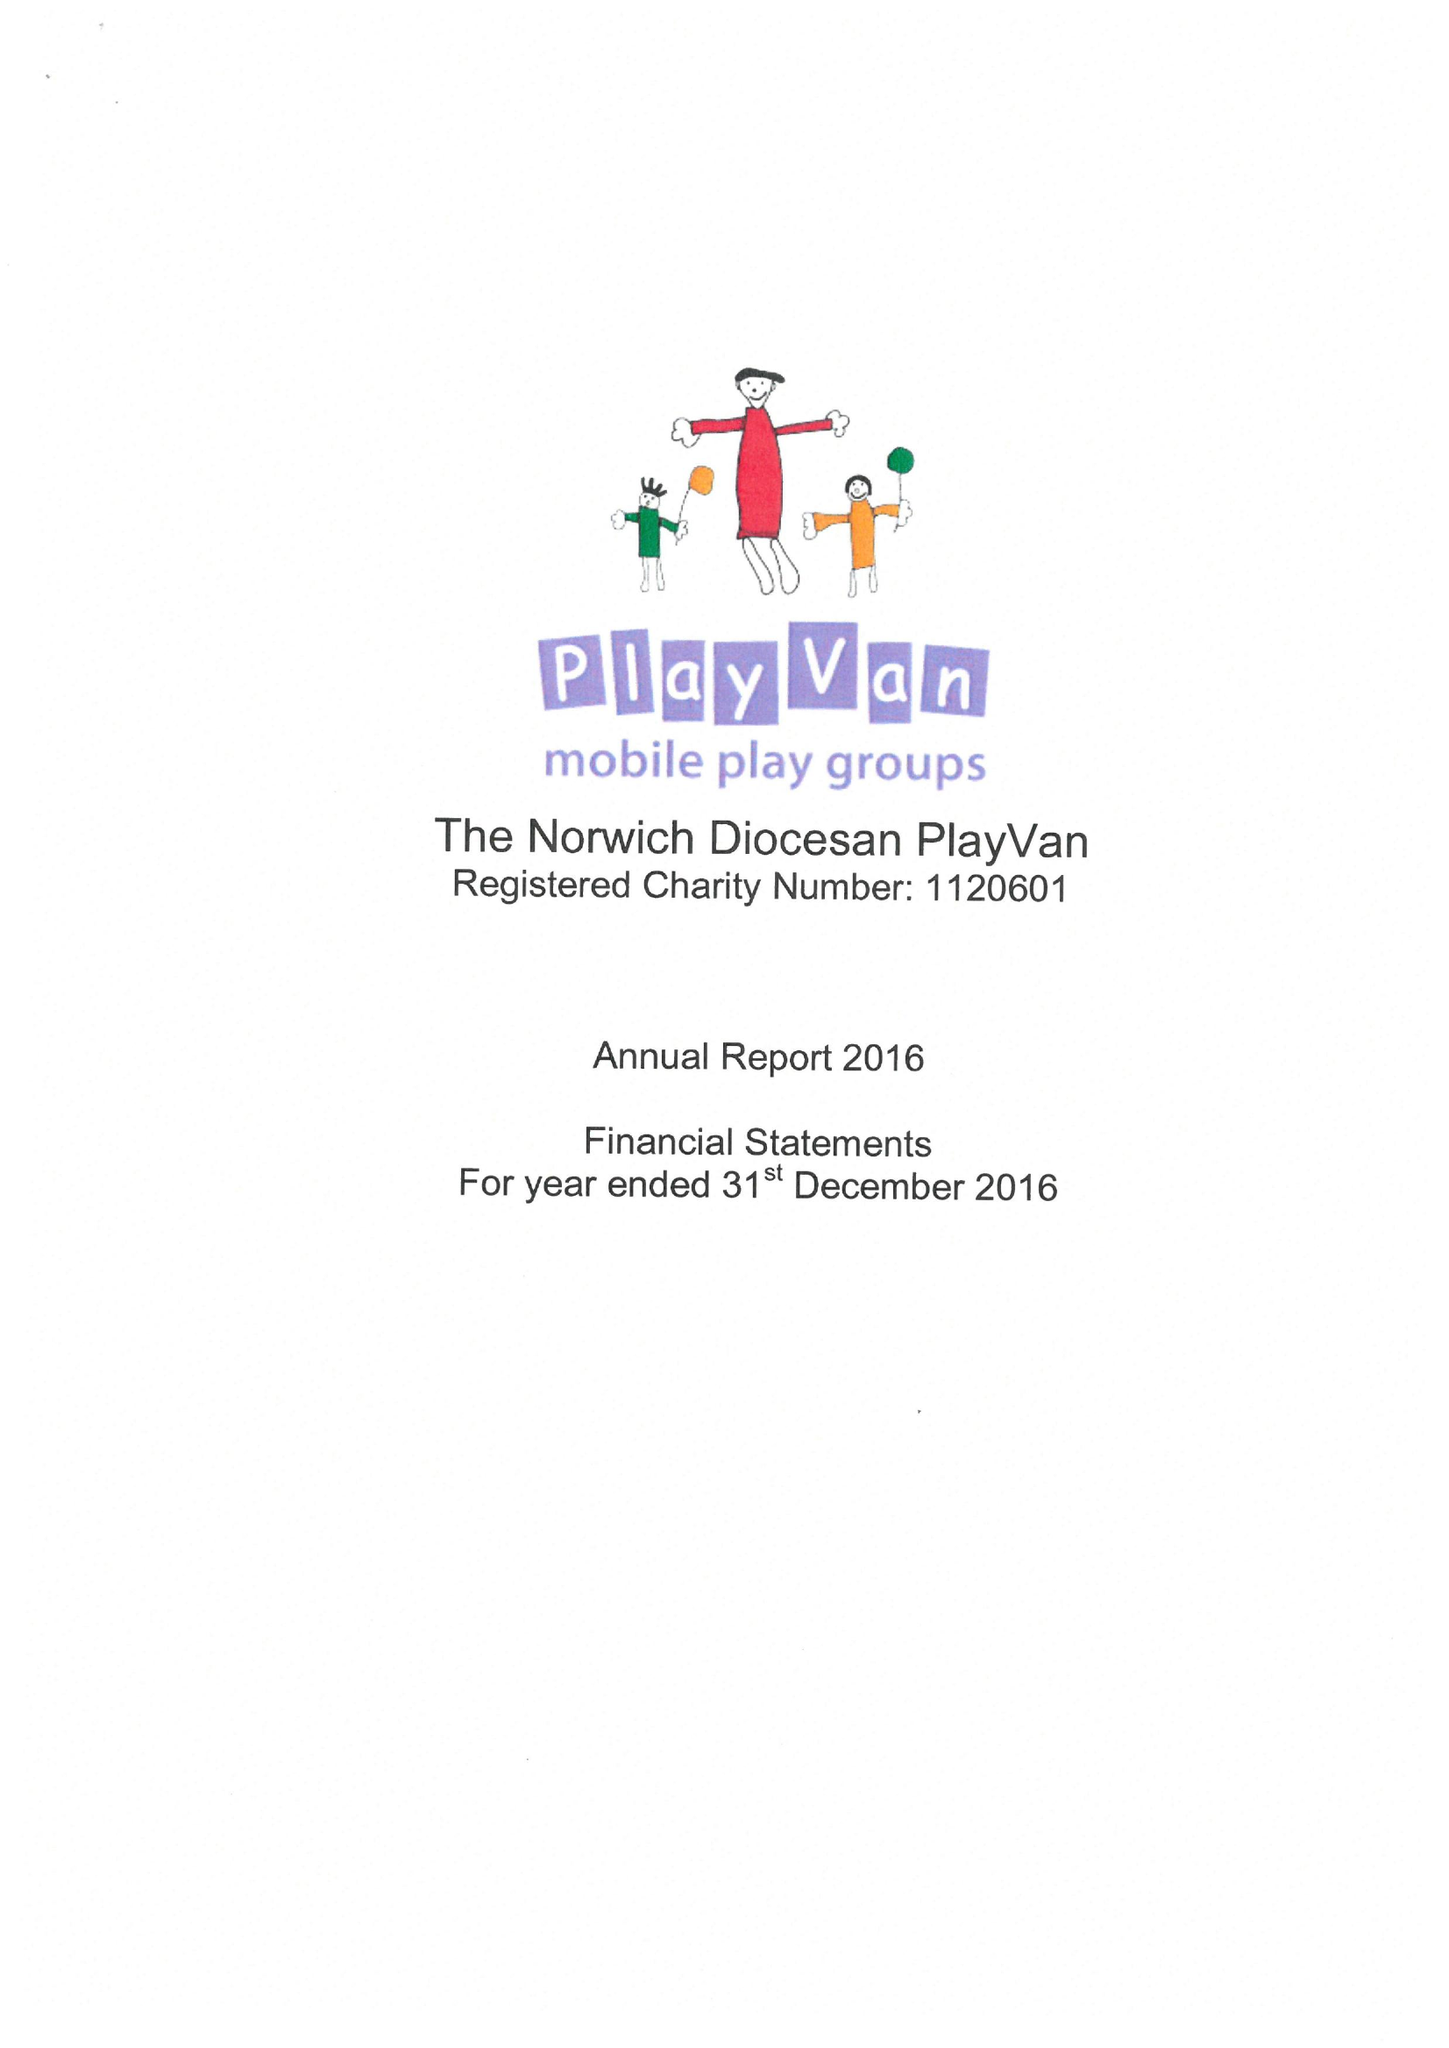What is the value for the spending_annually_in_british_pounds?
Answer the question using a single word or phrase. 18982.00 